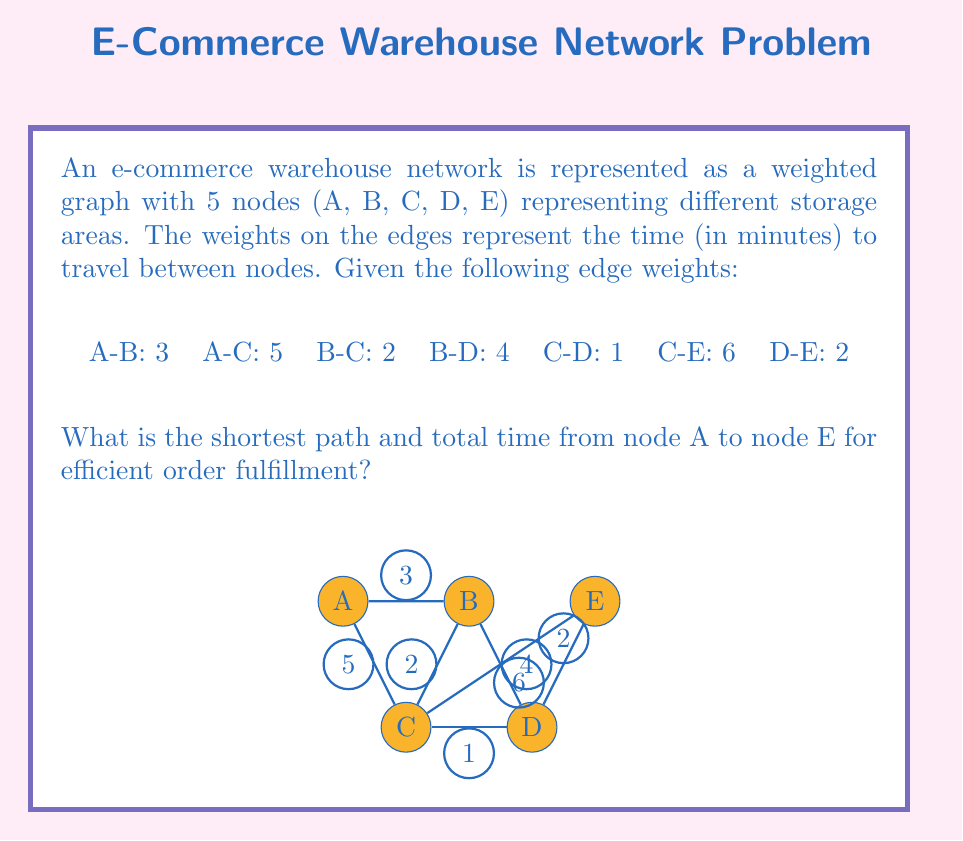Give your solution to this math problem. To solve this problem, we can use Dijkstra's algorithm to find the shortest path from node A to node E. Let's go through the steps:

1. Initialize distances:
   A: 0 (start node)
   B: ∞
   C: ∞
   D: ∞
   E: ∞

2. Visit node A:
   Update B: min(∞, 0 + 3) = 3
   Update C: min(∞, 0 + 5) = 5
   Distances: A(0), B(3), C(5), D(∞), E(∞)

3. Visit node B (closest unvisited node):
   Update C: min(5, 3 + 2) = 5 (no change)
   Update D: min(∞, 3 + 4) = 7
   Distances: A(0), B(3), C(5), D(7), E(∞)

4. Visit node C:
   Update D: min(7, 5 + 1) = 6
   Update E: min(∞, 5 + 6) = 11
   Distances: A(0), B(3), C(5), D(6), E(11)

5. Visit node D:
   Update E: min(11, 6 + 2) = 8
   Distances: A(0), B(3), C(5), D(6), E(8)

6. Visit node E (destination reached)

The shortest path is A -> B -> C -> D -> E with a total time of 8 minutes.

To verify:
A -> B: 3 minutes
B -> C: 2 minutes
C -> D: 1 minute
D -> E: 2 minutes
Total: 3 + 2 + 1 + 2 = 8 minutes
Answer: The shortest path is A -> B -> C -> D -> E, with a total time of 8 minutes. 